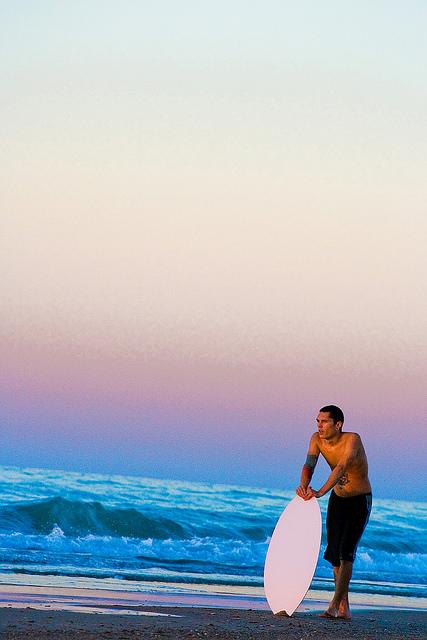What does the man have in his hands?
Quick response, please. Surfboard. Is the moon visible?
Be succinct. No. What is this person doing?
Write a very short answer. Standing. Does it appear to be sunrise or sunset?
Answer briefly. Sunrise. Is it a sunny day?
Answer briefly. Yes. 